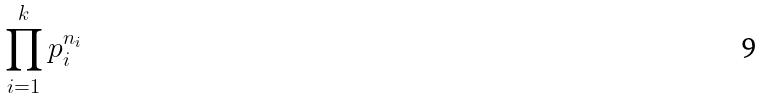<formula> <loc_0><loc_0><loc_500><loc_500>\prod _ { i = 1 } ^ { k } p _ { i } ^ { n _ { i } }</formula> 